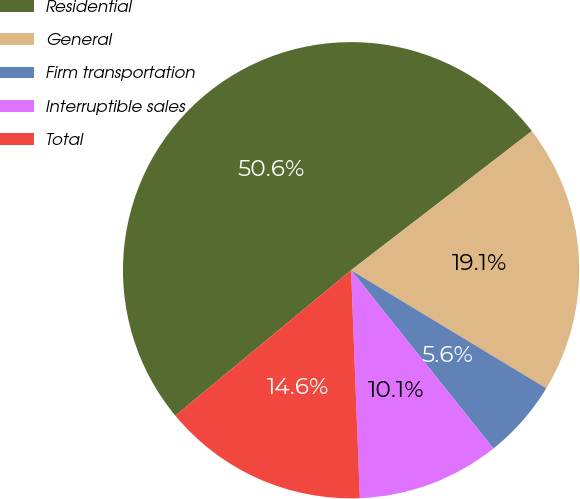Convert chart. <chart><loc_0><loc_0><loc_500><loc_500><pie_chart><fcel>Residential<fcel>General<fcel>Firm transportation<fcel>Interruptible sales<fcel>Total<nl><fcel>50.56%<fcel>19.1%<fcel>5.62%<fcel>10.11%<fcel>14.61%<nl></chart> 